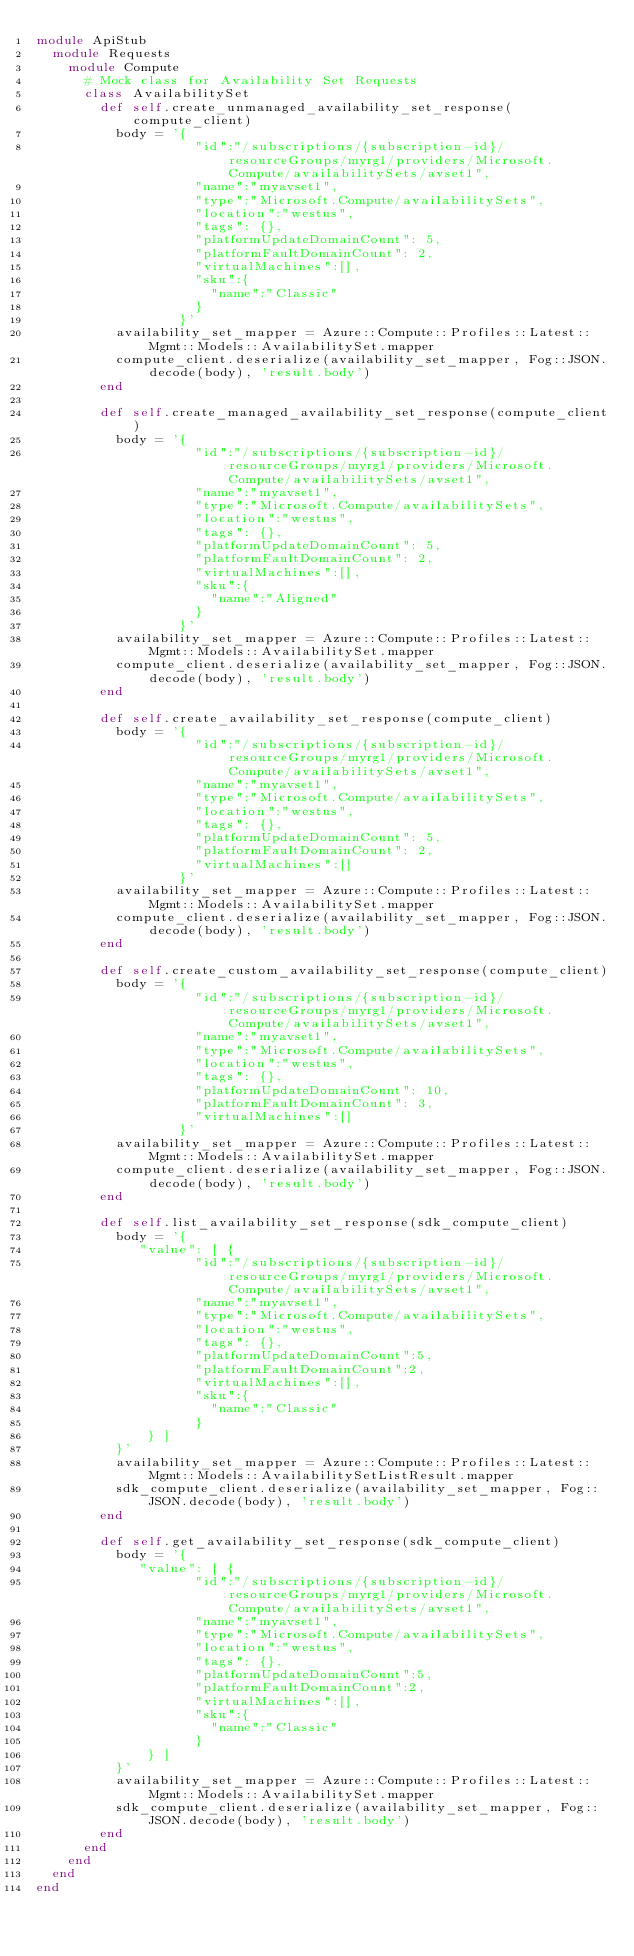<code> <loc_0><loc_0><loc_500><loc_500><_Ruby_>module ApiStub
  module Requests
    module Compute
      # Mock class for Availability Set Requests
      class AvailabilitySet
        def self.create_unmanaged_availability_set_response(compute_client)
          body = '{
                    "id":"/subscriptions/{subscription-id}/resourceGroups/myrg1/providers/Microsoft.Compute/availabilitySets/avset1",
                    "name":"myavset1",
                    "type":"Microsoft.Compute/availabilitySets",
                    "location":"westus",
                    "tags": {},
                    "platformUpdateDomainCount": 5,
                    "platformFaultDomainCount": 2,
                    "virtualMachines":[],
                    "sku":{
                      "name":"Classic"
                    }
                  }'
          availability_set_mapper = Azure::Compute::Profiles::Latest::Mgmt::Models::AvailabilitySet.mapper
          compute_client.deserialize(availability_set_mapper, Fog::JSON.decode(body), 'result.body')
        end

        def self.create_managed_availability_set_response(compute_client)
          body = '{
                    "id":"/subscriptions/{subscription-id}/resourceGroups/myrg1/providers/Microsoft.Compute/availabilitySets/avset1",
                    "name":"myavset1",
                    "type":"Microsoft.Compute/availabilitySets",
                    "location":"westus",
                    "tags": {},
                    "platformUpdateDomainCount": 5,
                    "platformFaultDomainCount": 2,
                    "virtualMachines":[],
                    "sku":{
                      "name":"Aligned"
                    }
                  }'
          availability_set_mapper = Azure::Compute::Profiles::Latest::Mgmt::Models::AvailabilitySet.mapper
          compute_client.deserialize(availability_set_mapper, Fog::JSON.decode(body), 'result.body')
        end

        def self.create_availability_set_response(compute_client)
          body = '{
                    "id":"/subscriptions/{subscription-id}/resourceGroups/myrg1/providers/Microsoft.Compute/availabilitySets/avset1",
                    "name":"myavset1",
                    "type":"Microsoft.Compute/availabilitySets",
                    "location":"westus",
                    "tags": {},
                    "platformUpdateDomainCount": 5,
                    "platformFaultDomainCount": 2,
                    "virtualMachines":[]
                  }'
          availability_set_mapper = Azure::Compute::Profiles::Latest::Mgmt::Models::AvailabilitySet.mapper
          compute_client.deserialize(availability_set_mapper, Fog::JSON.decode(body), 'result.body')
        end

        def self.create_custom_availability_set_response(compute_client)
          body = '{
                    "id":"/subscriptions/{subscription-id}/resourceGroups/myrg1/providers/Microsoft.Compute/availabilitySets/avset1",
                    "name":"myavset1",
                    "type":"Microsoft.Compute/availabilitySets",
                    "location":"westus",
                    "tags": {},
                    "platformUpdateDomainCount": 10,
                    "platformFaultDomainCount": 3,
                    "virtualMachines":[]
                  }'
          availability_set_mapper = Azure::Compute::Profiles::Latest::Mgmt::Models::AvailabilitySet.mapper
          compute_client.deserialize(availability_set_mapper, Fog::JSON.decode(body), 'result.body')
        end

        def self.list_availability_set_response(sdk_compute_client)
          body = '{
             "value": [ {
                    "id":"/subscriptions/{subscription-id}/resourceGroups/myrg1/providers/Microsoft.Compute/availabilitySets/avset1",
                    "name":"myavset1",
                    "type":"Microsoft.Compute/availabilitySets",
                    "location":"westus",
                    "tags": {},
                    "platformUpdateDomainCount":5,
                    "platformFaultDomainCount":2,
                    "virtualMachines":[],
                    "sku":{
                      "name":"Classic"
                    }
              } ]
          }'
          availability_set_mapper = Azure::Compute::Profiles::Latest::Mgmt::Models::AvailabilitySetListResult.mapper
          sdk_compute_client.deserialize(availability_set_mapper, Fog::JSON.decode(body), 'result.body')
        end

        def self.get_availability_set_response(sdk_compute_client)
          body = '{
             "value": [ {
                    "id":"/subscriptions/{subscription-id}/resourceGroups/myrg1/providers/Microsoft.Compute/availabilitySets/avset1",
                    "name":"myavset1",
                    "type":"Microsoft.Compute/availabilitySets",
                    "location":"westus",
                    "tags": {},
                    "platformUpdateDomainCount":5,
                    "platformFaultDomainCount":2,
                    "virtualMachines":[],
                    "sku":{
                      "name":"Classic"
                    }
              } ]
          }'
          availability_set_mapper = Azure::Compute::Profiles::Latest::Mgmt::Models::AvailabilitySet.mapper
          sdk_compute_client.deserialize(availability_set_mapper, Fog::JSON.decode(body), 'result.body')
        end
      end
    end
  end
end
</code> 